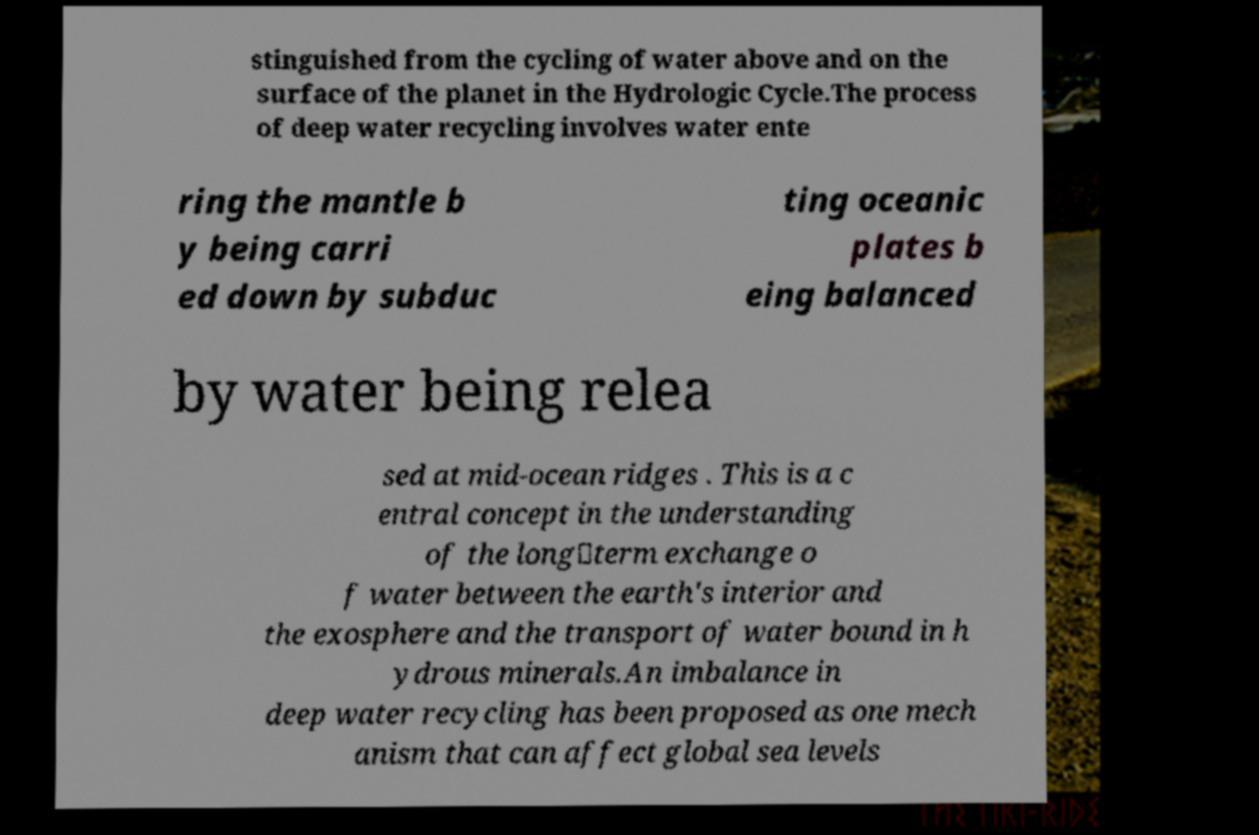Please read and relay the text visible in this image. What does it say? stinguished from the cycling of water above and on the surface of the planet in the Hydrologic Cycle.The process of deep water recycling involves water ente ring the mantle b y being carri ed down by subduc ting oceanic plates b eing balanced by water being relea sed at mid-ocean ridges . This is a c entral concept in the understanding of the long‐term exchange o f water between the earth's interior and the exosphere and the transport of water bound in h ydrous minerals.An imbalance in deep water recycling has been proposed as one mech anism that can affect global sea levels 